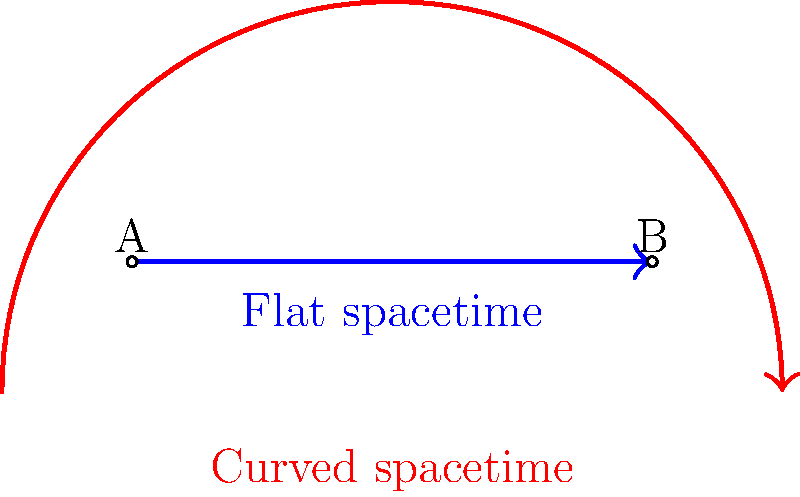In the context of non-Euclidean geometry and general relativity, the image above represents light paths in flat and curved spacetime. How does the presence of massive objects affect the path of light, and what implications does this have for our understanding of the universe? To understand the difference between light paths in flat and curved spacetime, let's follow these steps:

1. Flat spacetime (blue line):
   - In the absence of massive objects, spacetime is flat.
   - Light travels in straight lines, following the shortest path between two points.
   - This is consistent with Euclidean geometry.

2. Curved spacetime (red arc):
   - Massive objects (like stars, planets, or black holes) curve spacetime around them.
   - This curvature affects the path of light, causing it to bend.
   - The path of light follows geodesics, which are the shortest paths in curved spacetime.

3. Effects of curved spacetime:
   - Gravitational lensing: Light from distant objects can be bent around massive objects, creating multiple images or distortions.
   - Time dilation: Time passes more slowly in regions of stronger gravitational fields.
   - Gravitational redshift: Light moving out of a gravitational field loses energy, shifting to longer wavelengths.

4. Implications for our understanding of the universe:
   - The fabric of spacetime is dynamic and influenced by the distribution of matter and energy.
   - Gravity is not a force, but a consequence of the curvature of spacetime (Einstein's General Relativity).
   - Our perception of straight lines and Euclidean geometry is an approximation valid only in weak gravitational fields.

5. Connection to secular humanism:
   - This understanding of the universe emphasizes the importance of scientific inquiry and empirical evidence in shaping our worldview.
   - It demonstrates how our understanding of reality can evolve through observation and mathematical modeling, independent of religious doctrine.

The curved path of light in the presence of massive objects reveals the fundamental nature of spacetime and gravity, challenging our intuitive notions of geometry and providing a more accurate description of the cosmos.
Answer: Massive objects curve spacetime, causing light to follow geodesics rather than straight lines, revealing the dynamic nature of the universe's geometry. 